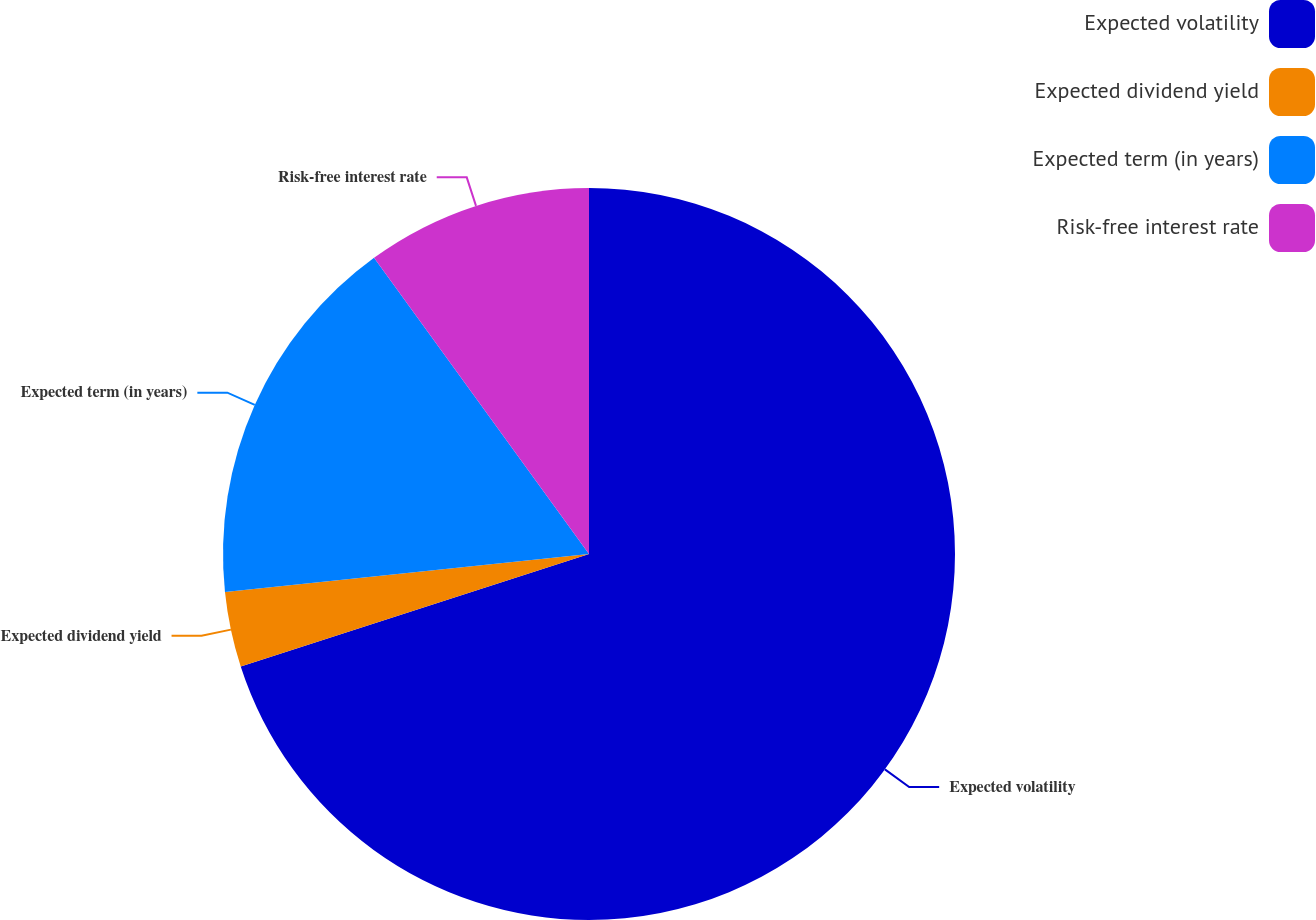Convert chart to OTSL. <chart><loc_0><loc_0><loc_500><loc_500><pie_chart><fcel>Expected volatility<fcel>Expected dividend yield<fcel>Expected term (in years)<fcel>Risk-free interest rate<nl><fcel>70.02%<fcel>3.32%<fcel>16.66%<fcel>9.99%<nl></chart> 